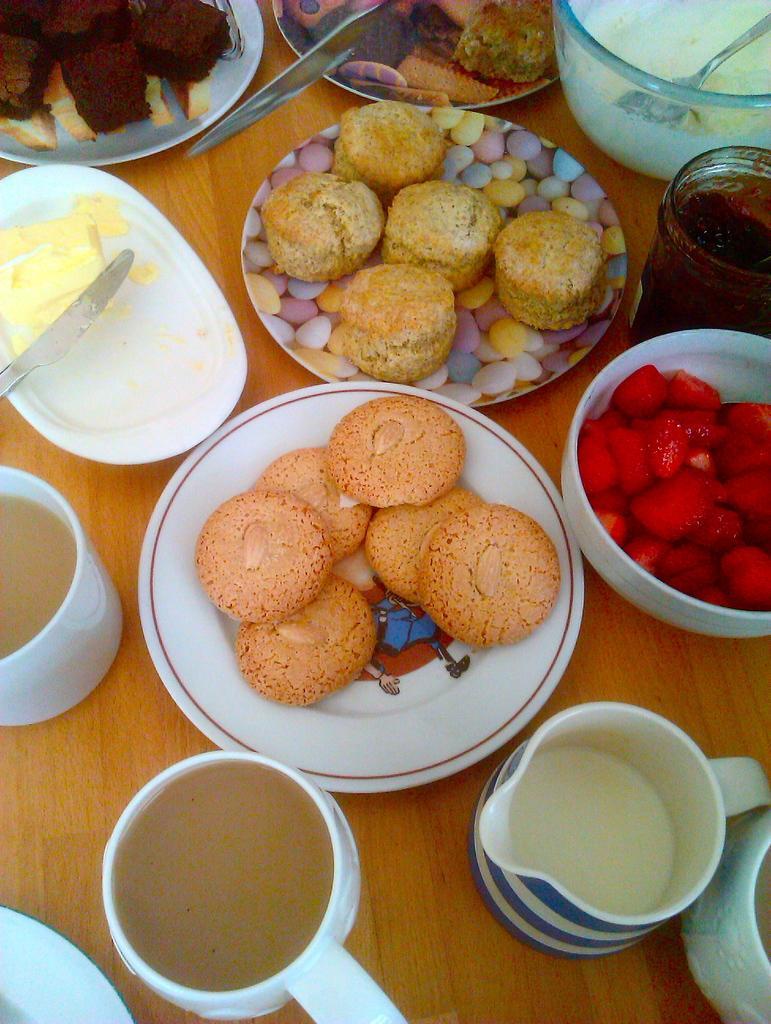Please provide a concise description of this image. This picture shows biscuits and muffins and some food in the plates and see cheese in another plate and few strawberry pieces in a bowl and few cups on the table and we see a bowl with some food and a spoon. 